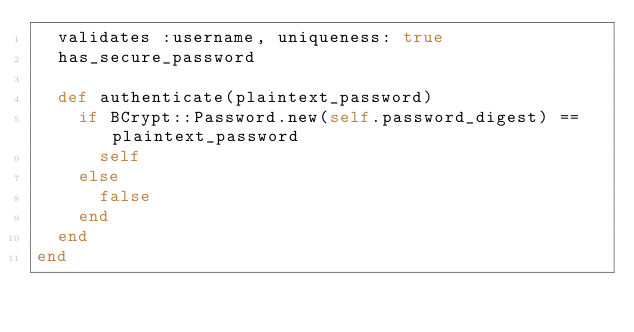Convert code to text. <code><loc_0><loc_0><loc_500><loc_500><_Ruby_>  validates :username, uniqueness: true
  has_secure_password

  def authenticate(plaintext_password)
    if BCrypt::Password.new(self.password_digest) == plaintext_password
      self
    else
      false
    end
  end
end
</code> 